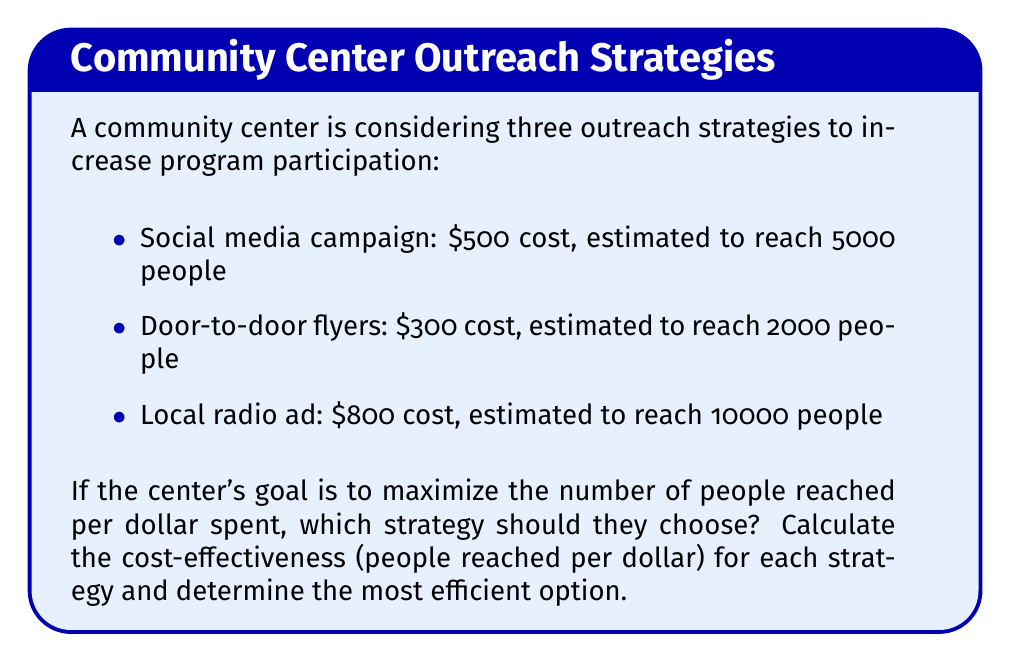Show me your answer to this math problem. To solve this problem, we need to calculate the cost-effectiveness of each strategy by dividing the number of people reached by the cost. This will give us the number of people reached per dollar spent.

1. Social media campaign:
   Cost-effectiveness = People reached / Cost
   $$ \frac{5000 \text{ people}}{\$500} = 10 \text{ people/dollar} $$

2. Door-to-door flyers:
   $$ \frac{2000 \text{ people}}{\$300} = 6.67 \text{ people/dollar} $$

3. Local radio ad:
   $$ \frac{10000 \text{ people}}{\$800} = 12.5 \text{ people/dollar} $$

Comparing the results:
- Social media campaign: 10 people/dollar
- Door-to-door flyers: 6.67 people/dollar
- Local radio ad: 12.5 people/dollar

The local radio ad has the highest cost-effectiveness, reaching 12.5 people per dollar spent.
Answer: Local radio ad (12.5 people/dollar) 